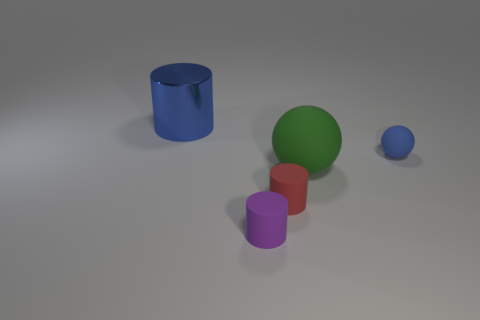Is the small blue matte thing the same shape as the small red thing? No, the small blue object is a sphere, while the small red object is a cylinder. Despite both being small and having distinct colors, their shapes are fundamentally different: one is round with a continuous surface, and the other has two flat circular faces connected by a curved side. 